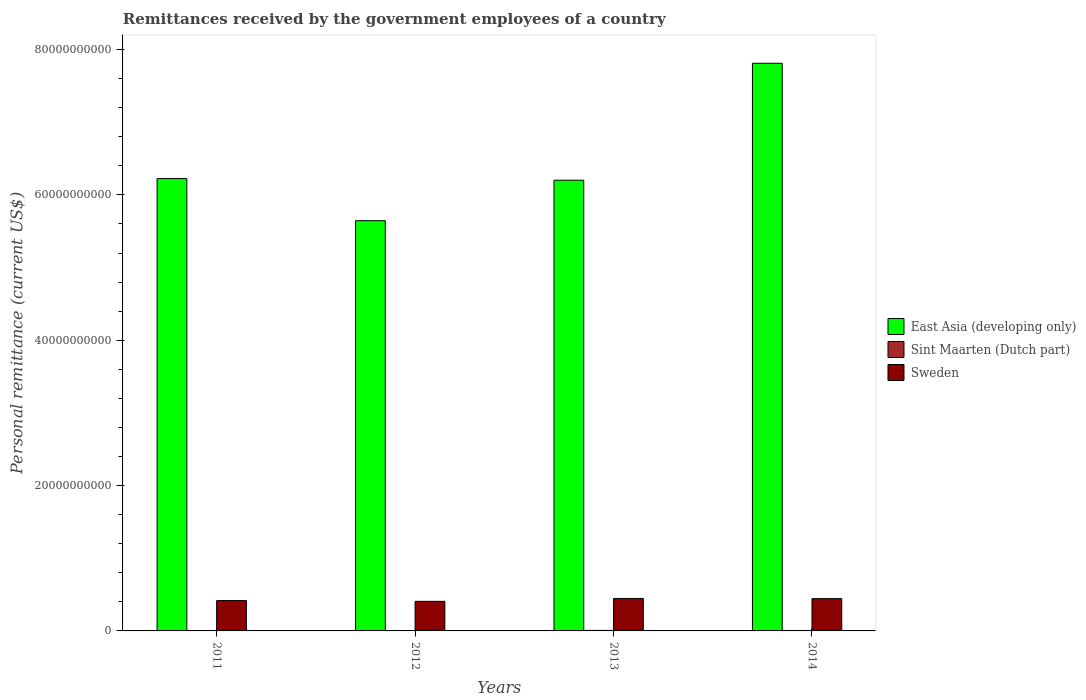How many groups of bars are there?
Keep it short and to the point. 4. Are the number of bars per tick equal to the number of legend labels?
Your answer should be very brief. Yes. Are the number of bars on each tick of the X-axis equal?
Your answer should be very brief. Yes. What is the label of the 3rd group of bars from the left?
Provide a succinct answer. 2013. What is the remittances received by the government employees in Sweden in 2012?
Your answer should be compact. 4.07e+09. Across all years, what is the maximum remittances received by the government employees in East Asia (developing only)?
Provide a succinct answer. 7.81e+1. Across all years, what is the minimum remittances received by the government employees in Sweden?
Make the answer very short. 4.07e+09. What is the total remittances received by the government employees in East Asia (developing only) in the graph?
Provide a succinct answer. 2.59e+11. What is the difference between the remittances received by the government employees in Sweden in 2011 and that in 2013?
Offer a very short reply. -2.91e+08. What is the difference between the remittances received by the government employees in East Asia (developing only) in 2011 and the remittances received by the government employees in Sint Maarten (Dutch part) in 2012?
Make the answer very short. 6.22e+1. What is the average remittances received by the government employees in East Asia (developing only) per year?
Give a very brief answer. 6.47e+1. In the year 2013, what is the difference between the remittances received by the government employees in Sweden and remittances received by the government employees in Sint Maarten (Dutch part)?
Offer a terse response. 4.39e+09. What is the ratio of the remittances received by the government employees in Sweden in 2012 to that in 2013?
Your response must be concise. 0.91. Is the remittances received by the government employees in Sint Maarten (Dutch part) in 2011 less than that in 2013?
Your answer should be compact. Yes. Is the difference between the remittances received by the government employees in Sweden in 2012 and 2014 greater than the difference between the remittances received by the government employees in Sint Maarten (Dutch part) in 2012 and 2014?
Your answer should be compact. No. What is the difference between the highest and the second highest remittances received by the government employees in Sweden?
Give a very brief answer. 2.38e+07. What is the difference between the highest and the lowest remittances received by the government employees in Sint Maarten (Dutch part)?
Your response must be concise. 1.85e+07. What does the 2nd bar from the left in 2012 represents?
Offer a very short reply. Sint Maarten (Dutch part). What does the 1st bar from the right in 2012 represents?
Provide a succinct answer. Sweden. How many bars are there?
Your answer should be compact. 12. Are all the bars in the graph horizontal?
Offer a very short reply. No. How many years are there in the graph?
Offer a terse response. 4. Are the values on the major ticks of Y-axis written in scientific E-notation?
Provide a succinct answer. No. Does the graph contain any zero values?
Keep it short and to the point. No. Does the graph contain grids?
Make the answer very short. No. How many legend labels are there?
Offer a terse response. 3. How are the legend labels stacked?
Your response must be concise. Vertical. What is the title of the graph?
Provide a succinct answer. Remittances received by the government employees of a country. Does "St. Martin (French part)" appear as one of the legend labels in the graph?
Provide a short and direct response. No. What is the label or title of the Y-axis?
Provide a short and direct response. Personal remittance (current US$). What is the Personal remittance (current US$) in East Asia (developing only) in 2011?
Provide a succinct answer. 6.22e+1. What is the Personal remittance (current US$) in Sint Maarten (Dutch part) in 2011?
Your answer should be very brief. 5.41e+07. What is the Personal remittance (current US$) of Sweden in 2011?
Keep it short and to the point. 4.18e+09. What is the Personal remittance (current US$) of East Asia (developing only) in 2012?
Ensure brevity in your answer.  5.65e+1. What is the Personal remittance (current US$) in Sint Maarten (Dutch part) in 2012?
Your response must be concise. 5.57e+07. What is the Personal remittance (current US$) of Sweden in 2012?
Give a very brief answer. 4.07e+09. What is the Personal remittance (current US$) of East Asia (developing only) in 2013?
Offer a terse response. 6.20e+1. What is the Personal remittance (current US$) in Sint Maarten (Dutch part) in 2013?
Make the answer very short. 7.25e+07. What is the Personal remittance (current US$) in Sweden in 2013?
Provide a short and direct response. 4.47e+09. What is the Personal remittance (current US$) of East Asia (developing only) in 2014?
Your answer should be compact. 7.81e+1. What is the Personal remittance (current US$) in Sint Maarten (Dutch part) in 2014?
Make the answer very short. 6.21e+07. What is the Personal remittance (current US$) in Sweden in 2014?
Make the answer very short. 4.44e+09. Across all years, what is the maximum Personal remittance (current US$) in East Asia (developing only)?
Your answer should be compact. 7.81e+1. Across all years, what is the maximum Personal remittance (current US$) in Sint Maarten (Dutch part)?
Make the answer very short. 7.25e+07. Across all years, what is the maximum Personal remittance (current US$) of Sweden?
Offer a terse response. 4.47e+09. Across all years, what is the minimum Personal remittance (current US$) of East Asia (developing only)?
Ensure brevity in your answer.  5.65e+1. Across all years, what is the minimum Personal remittance (current US$) of Sint Maarten (Dutch part)?
Provide a succinct answer. 5.41e+07. Across all years, what is the minimum Personal remittance (current US$) of Sweden?
Offer a very short reply. 4.07e+09. What is the total Personal remittance (current US$) in East Asia (developing only) in the graph?
Offer a terse response. 2.59e+11. What is the total Personal remittance (current US$) of Sint Maarten (Dutch part) in the graph?
Your answer should be very brief. 2.44e+08. What is the total Personal remittance (current US$) in Sweden in the graph?
Make the answer very short. 1.72e+1. What is the difference between the Personal remittance (current US$) in East Asia (developing only) in 2011 and that in 2012?
Your answer should be compact. 5.79e+09. What is the difference between the Personal remittance (current US$) in Sint Maarten (Dutch part) in 2011 and that in 2012?
Provide a succinct answer. -1.58e+06. What is the difference between the Personal remittance (current US$) in Sweden in 2011 and that in 2012?
Keep it short and to the point. 1.06e+08. What is the difference between the Personal remittance (current US$) in East Asia (developing only) in 2011 and that in 2013?
Provide a succinct answer. 2.23e+08. What is the difference between the Personal remittance (current US$) of Sint Maarten (Dutch part) in 2011 and that in 2013?
Provide a succinct answer. -1.85e+07. What is the difference between the Personal remittance (current US$) of Sweden in 2011 and that in 2013?
Your response must be concise. -2.91e+08. What is the difference between the Personal remittance (current US$) of East Asia (developing only) in 2011 and that in 2014?
Give a very brief answer. -1.59e+1. What is the difference between the Personal remittance (current US$) of Sint Maarten (Dutch part) in 2011 and that in 2014?
Provide a short and direct response. -8.03e+06. What is the difference between the Personal remittance (current US$) of Sweden in 2011 and that in 2014?
Offer a very short reply. -2.67e+08. What is the difference between the Personal remittance (current US$) in East Asia (developing only) in 2012 and that in 2013?
Your answer should be very brief. -5.57e+09. What is the difference between the Personal remittance (current US$) of Sint Maarten (Dutch part) in 2012 and that in 2013?
Ensure brevity in your answer.  -1.69e+07. What is the difference between the Personal remittance (current US$) in Sweden in 2012 and that in 2013?
Give a very brief answer. -3.96e+08. What is the difference between the Personal remittance (current US$) in East Asia (developing only) in 2012 and that in 2014?
Your answer should be very brief. -2.17e+1. What is the difference between the Personal remittance (current US$) in Sint Maarten (Dutch part) in 2012 and that in 2014?
Your answer should be compact. -6.45e+06. What is the difference between the Personal remittance (current US$) of Sweden in 2012 and that in 2014?
Provide a short and direct response. -3.72e+08. What is the difference between the Personal remittance (current US$) in East Asia (developing only) in 2013 and that in 2014?
Your answer should be compact. -1.61e+1. What is the difference between the Personal remittance (current US$) in Sint Maarten (Dutch part) in 2013 and that in 2014?
Your answer should be very brief. 1.04e+07. What is the difference between the Personal remittance (current US$) of Sweden in 2013 and that in 2014?
Offer a very short reply. 2.38e+07. What is the difference between the Personal remittance (current US$) in East Asia (developing only) in 2011 and the Personal remittance (current US$) in Sint Maarten (Dutch part) in 2012?
Your answer should be compact. 6.22e+1. What is the difference between the Personal remittance (current US$) in East Asia (developing only) in 2011 and the Personal remittance (current US$) in Sweden in 2012?
Make the answer very short. 5.82e+1. What is the difference between the Personal remittance (current US$) of Sint Maarten (Dutch part) in 2011 and the Personal remittance (current US$) of Sweden in 2012?
Make the answer very short. -4.02e+09. What is the difference between the Personal remittance (current US$) of East Asia (developing only) in 2011 and the Personal remittance (current US$) of Sint Maarten (Dutch part) in 2013?
Your response must be concise. 6.22e+1. What is the difference between the Personal remittance (current US$) of East Asia (developing only) in 2011 and the Personal remittance (current US$) of Sweden in 2013?
Your answer should be compact. 5.78e+1. What is the difference between the Personal remittance (current US$) in Sint Maarten (Dutch part) in 2011 and the Personal remittance (current US$) in Sweden in 2013?
Provide a short and direct response. -4.41e+09. What is the difference between the Personal remittance (current US$) of East Asia (developing only) in 2011 and the Personal remittance (current US$) of Sint Maarten (Dutch part) in 2014?
Offer a very short reply. 6.22e+1. What is the difference between the Personal remittance (current US$) in East Asia (developing only) in 2011 and the Personal remittance (current US$) in Sweden in 2014?
Keep it short and to the point. 5.78e+1. What is the difference between the Personal remittance (current US$) in Sint Maarten (Dutch part) in 2011 and the Personal remittance (current US$) in Sweden in 2014?
Offer a terse response. -4.39e+09. What is the difference between the Personal remittance (current US$) in East Asia (developing only) in 2012 and the Personal remittance (current US$) in Sint Maarten (Dutch part) in 2013?
Keep it short and to the point. 5.64e+1. What is the difference between the Personal remittance (current US$) of East Asia (developing only) in 2012 and the Personal remittance (current US$) of Sweden in 2013?
Provide a short and direct response. 5.20e+1. What is the difference between the Personal remittance (current US$) of Sint Maarten (Dutch part) in 2012 and the Personal remittance (current US$) of Sweden in 2013?
Make the answer very short. -4.41e+09. What is the difference between the Personal remittance (current US$) of East Asia (developing only) in 2012 and the Personal remittance (current US$) of Sint Maarten (Dutch part) in 2014?
Your answer should be compact. 5.64e+1. What is the difference between the Personal remittance (current US$) of East Asia (developing only) in 2012 and the Personal remittance (current US$) of Sweden in 2014?
Your answer should be very brief. 5.20e+1. What is the difference between the Personal remittance (current US$) of Sint Maarten (Dutch part) in 2012 and the Personal remittance (current US$) of Sweden in 2014?
Your answer should be compact. -4.39e+09. What is the difference between the Personal remittance (current US$) of East Asia (developing only) in 2013 and the Personal remittance (current US$) of Sint Maarten (Dutch part) in 2014?
Offer a terse response. 6.20e+1. What is the difference between the Personal remittance (current US$) of East Asia (developing only) in 2013 and the Personal remittance (current US$) of Sweden in 2014?
Your answer should be very brief. 5.76e+1. What is the difference between the Personal remittance (current US$) of Sint Maarten (Dutch part) in 2013 and the Personal remittance (current US$) of Sweden in 2014?
Make the answer very short. -4.37e+09. What is the average Personal remittance (current US$) of East Asia (developing only) per year?
Your response must be concise. 6.47e+1. What is the average Personal remittance (current US$) in Sint Maarten (Dutch part) per year?
Your answer should be compact. 6.11e+07. What is the average Personal remittance (current US$) in Sweden per year?
Keep it short and to the point. 4.29e+09. In the year 2011, what is the difference between the Personal remittance (current US$) in East Asia (developing only) and Personal remittance (current US$) in Sint Maarten (Dutch part)?
Provide a succinct answer. 6.22e+1. In the year 2011, what is the difference between the Personal remittance (current US$) of East Asia (developing only) and Personal remittance (current US$) of Sweden?
Ensure brevity in your answer.  5.81e+1. In the year 2011, what is the difference between the Personal remittance (current US$) in Sint Maarten (Dutch part) and Personal remittance (current US$) in Sweden?
Keep it short and to the point. -4.12e+09. In the year 2012, what is the difference between the Personal remittance (current US$) of East Asia (developing only) and Personal remittance (current US$) of Sint Maarten (Dutch part)?
Provide a short and direct response. 5.64e+1. In the year 2012, what is the difference between the Personal remittance (current US$) in East Asia (developing only) and Personal remittance (current US$) in Sweden?
Provide a succinct answer. 5.24e+1. In the year 2012, what is the difference between the Personal remittance (current US$) of Sint Maarten (Dutch part) and Personal remittance (current US$) of Sweden?
Provide a short and direct response. -4.01e+09. In the year 2013, what is the difference between the Personal remittance (current US$) of East Asia (developing only) and Personal remittance (current US$) of Sint Maarten (Dutch part)?
Ensure brevity in your answer.  6.19e+1. In the year 2013, what is the difference between the Personal remittance (current US$) of East Asia (developing only) and Personal remittance (current US$) of Sweden?
Provide a succinct answer. 5.76e+1. In the year 2013, what is the difference between the Personal remittance (current US$) in Sint Maarten (Dutch part) and Personal remittance (current US$) in Sweden?
Offer a very short reply. -4.39e+09. In the year 2014, what is the difference between the Personal remittance (current US$) of East Asia (developing only) and Personal remittance (current US$) of Sint Maarten (Dutch part)?
Offer a very short reply. 7.80e+1. In the year 2014, what is the difference between the Personal remittance (current US$) in East Asia (developing only) and Personal remittance (current US$) in Sweden?
Make the answer very short. 7.37e+1. In the year 2014, what is the difference between the Personal remittance (current US$) of Sint Maarten (Dutch part) and Personal remittance (current US$) of Sweden?
Offer a very short reply. -4.38e+09. What is the ratio of the Personal remittance (current US$) in East Asia (developing only) in 2011 to that in 2012?
Offer a very short reply. 1.1. What is the ratio of the Personal remittance (current US$) in Sint Maarten (Dutch part) in 2011 to that in 2012?
Make the answer very short. 0.97. What is the ratio of the Personal remittance (current US$) of Sweden in 2011 to that in 2012?
Offer a terse response. 1.03. What is the ratio of the Personal remittance (current US$) in East Asia (developing only) in 2011 to that in 2013?
Your response must be concise. 1. What is the ratio of the Personal remittance (current US$) of Sint Maarten (Dutch part) in 2011 to that in 2013?
Offer a terse response. 0.75. What is the ratio of the Personal remittance (current US$) of Sweden in 2011 to that in 2013?
Ensure brevity in your answer.  0.93. What is the ratio of the Personal remittance (current US$) of East Asia (developing only) in 2011 to that in 2014?
Offer a terse response. 0.8. What is the ratio of the Personal remittance (current US$) in Sint Maarten (Dutch part) in 2011 to that in 2014?
Your answer should be very brief. 0.87. What is the ratio of the Personal remittance (current US$) of Sweden in 2011 to that in 2014?
Offer a very short reply. 0.94. What is the ratio of the Personal remittance (current US$) of East Asia (developing only) in 2012 to that in 2013?
Provide a succinct answer. 0.91. What is the ratio of the Personal remittance (current US$) of Sint Maarten (Dutch part) in 2012 to that in 2013?
Your answer should be compact. 0.77. What is the ratio of the Personal remittance (current US$) of Sweden in 2012 to that in 2013?
Ensure brevity in your answer.  0.91. What is the ratio of the Personal remittance (current US$) of East Asia (developing only) in 2012 to that in 2014?
Make the answer very short. 0.72. What is the ratio of the Personal remittance (current US$) of Sint Maarten (Dutch part) in 2012 to that in 2014?
Make the answer very short. 0.9. What is the ratio of the Personal remittance (current US$) in Sweden in 2012 to that in 2014?
Your answer should be very brief. 0.92. What is the ratio of the Personal remittance (current US$) in East Asia (developing only) in 2013 to that in 2014?
Your answer should be compact. 0.79. What is the ratio of the Personal remittance (current US$) in Sint Maarten (Dutch part) in 2013 to that in 2014?
Your answer should be very brief. 1.17. What is the difference between the highest and the second highest Personal remittance (current US$) of East Asia (developing only)?
Your answer should be compact. 1.59e+1. What is the difference between the highest and the second highest Personal remittance (current US$) in Sint Maarten (Dutch part)?
Your answer should be very brief. 1.04e+07. What is the difference between the highest and the second highest Personal remittance (current US$) in Sweden?
Offer a very short reply. 2.38e+07. What is the difference between the highest and the lowest Personal remittance (current US$) in East Asia (developing only)?
Provide a short and direct response. 2.17e+1. What is the difference between the highest and the lowest Personal remittance (current US$) of Sint Maarten (Dutch part)?
Your answer should be compact. 1.85e+07. What is the difference between the highest and the lowest Personal remittance (current US$) of Sweden?
Your answer should be compact. 3.96e+08. 